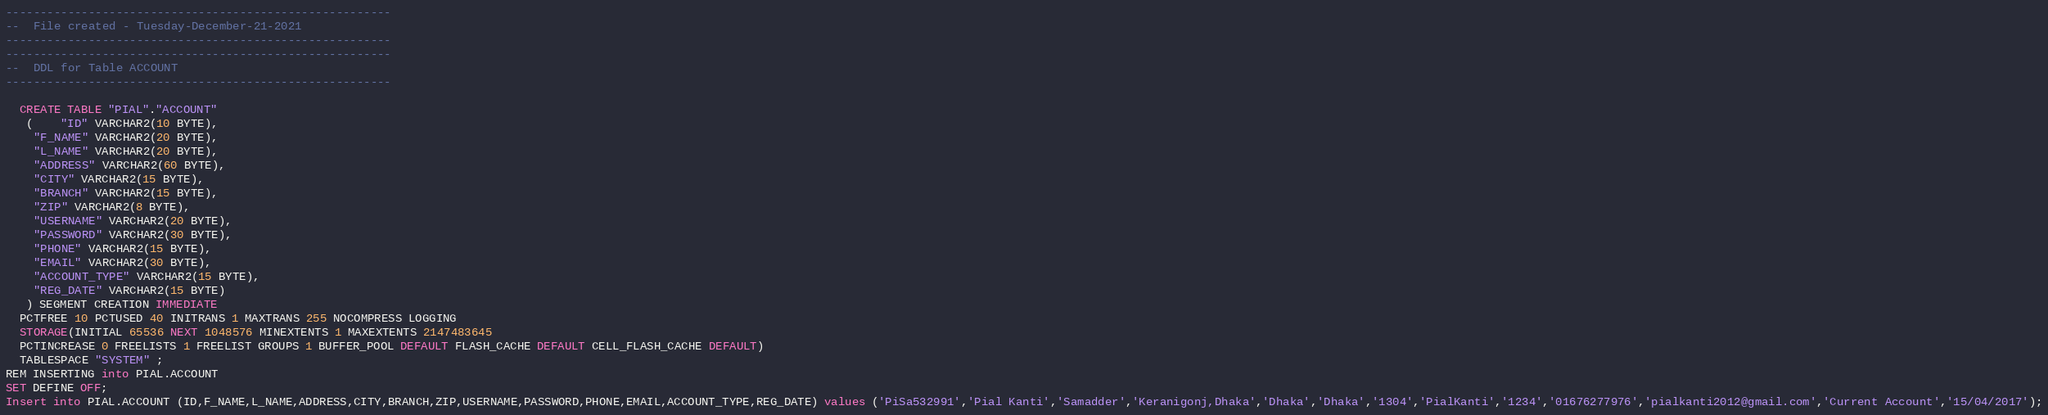<code> <loc_0><loc_0><loc_500><loc_500><_SQL_>--------------------------------------------------------
--  File created - Tuesday-December-21-2021 
--------------------------------------------------------
--------------------------------------------------------
--  DDL for Table ACCOUNT
--------------------------------------------------------

  CREATE TABLE "PIAL"."ACCOUNT" 
   (	"ID" VARCHAR2(10 BYTE), 
	"F_NAME" VARCHAR2(20 BYTE), 
	"L_NAME" VARCHAR2(20 BYTE), 
	"ADDRESS" VARCHAR2(60 BYTE), 
	"CITY" VARCHAR2(15 BYTE), 
	"BRANCH" VARCHAR2(15 BYTE), 
	"ZIP" VARCHAR2(8 BYTE), 
	"USERNAME" VARCHAR2(20 BYTE), 
	"PASSWORD" VARCHAR2(30 BYTE), 
	"PHONE" VARCHAR2(15 BYTE), 
	"EMAIL" VARCHAR2(30 BYTE), 
	"ACCOUNT_TYPE" VARCHAR2(15 BYTE), 
	"REG_DATE" VARCHAR2(15 BYTE)
   ) SEGMENT CREATION IMMEDIATE 
  PCTFREE 10 PCTUSED 40 INITRANS 1 MAXTRANS 255 NOCOMPRESS LOGGING
  STORAGE(INITIAL 65536 NEXT 1048576 MINEXTENTS 1 MAXEXTENTS 2147483645
  PCTINCREASE 0 FREELISTS 1 FREELIST GROUPS 1 BUFFER_POOL DEFAULT FLASH_CACHE DEFAULT CELL_FLASH_CACHE DEFAULT)
  TABLESPACE "SYSTEM" ;
REM INSERTING into PIAL.ACCOUNT
SET DEFINE OFF;
Insert into PIAL.ACCOUNT (ID,F_NAME,L_NAME,ADDRESS,CITY,BRANCH,ZIP,USERNAME,PASSWORD,PHONE,EMAIL,ACCOUNT_TYPE,REG_DATE) values ('PiSa532991','Pial Kanti','Samadder','Keranigonj,Dhaka','Dhaka','Dhaka','1304','PialKanti','1234','01676277976','pialkanti2012@gmail.com','Current Account','15/04/2017');</code> 